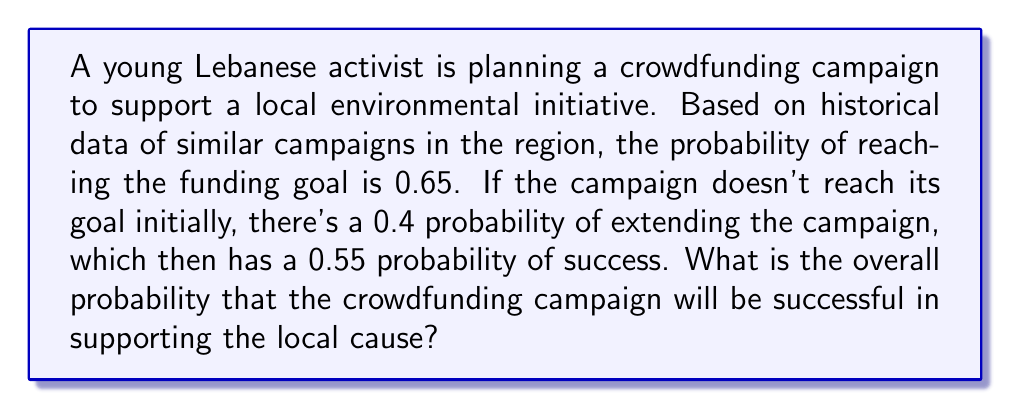Give your solution to this math problem. Let's approach this step-by-step using the law of total probability:

1) Let's define our events:
   A: The campaign is successful
   B: The campaign reaches its goal initially
   C: The campaign is extended

2) We're given the following probabilities:
   $P(B) = 0.65$ (probability of reaching the goal initially)
   $P(C|B^c) = 0.4$ (probability of extending given it didn't reach the goal initially)
   $P(A|C) = 0.55$ (probability of success given it was extended)

3) We can calculate $P(A)$ using the law of total probability:

   $P(A) = P(A|B)P(B) + P(A|B^c)P(B^c)$

4) We know that $P(A|B) = 1$ because if it reaches its goal initially, it's successful.

5) We need to calculate $P(A|B^c)$:
   $P(A|B^c) = P(A|C)P(C|B^c) = 0.55 \times 0.4 = 0.22$

6) Now we can plug everything into our formula:

   $P(A) = 1 \times 0.65 + 0.22 \times (1 - 0.65)$
   
   $= 0.65 + 0.22 \times 0.35$
   
   $= 0.65 + 0.077$
   
   $= 0.727$

Therefore, the overall probability of the campaign being successful is 0.727 or 72.7%.
Answer: The overall probability that the crowdfunding campaign will be successful is 0.727 or 72.7%. 